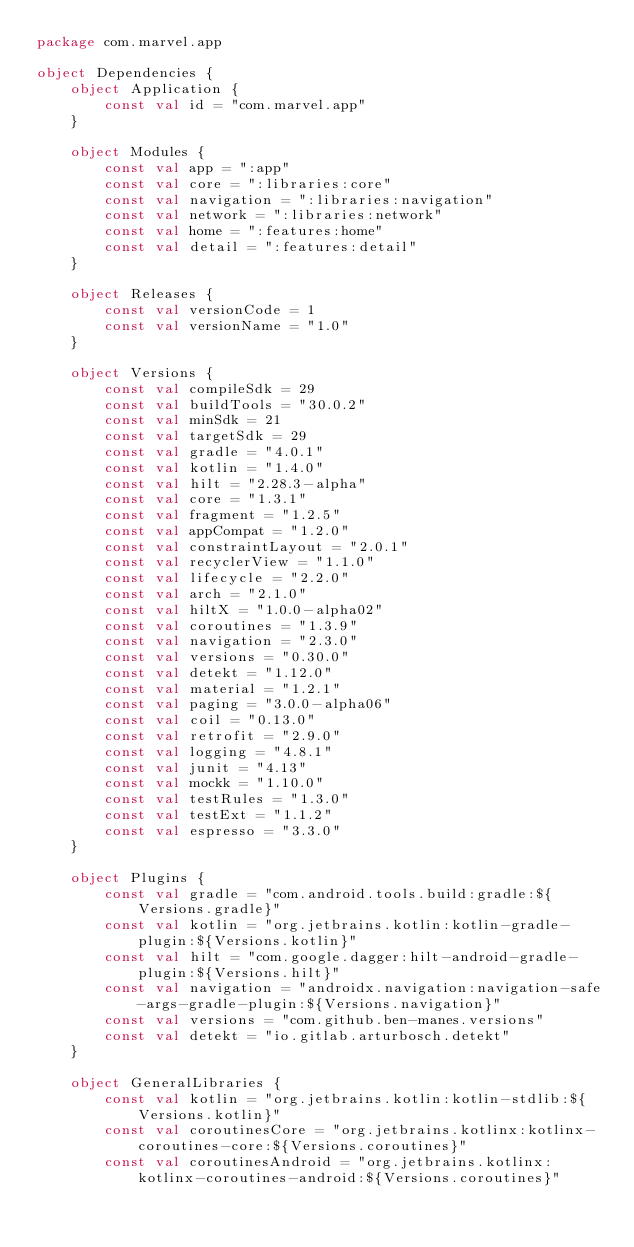<code> <loc_0><loc_0><loc_500><loc_500><_Kotlin_>package com.marvel.app

object Dependencies {
    object Application {
        const val id = "com.marvel.app"
    }

    object Modules {
        const val app = ":app"
        const val core = ":libraries:core"
        const val navigation = ":libraries:navigation"
        const val network = ":libraries:network"
        const val home = ":features:home"
        const val detail = ":features:detail"
    }

    object Releases {
        const val versionCode = 1
        const val versionName = "1.0"
    }

    object Versions {
        const val compileSdk = 29
        const val buildTools = "30.0.2"
        const val minSdk = 21
        const val targetSdk = 29
        const val gradle = "4.0.1"
        const val kotlin = "1.4.0"
        const val hilt = "2.28.3-alpha"
        const val core = "1.3.1"
        const val fragment = "1.2.5"
        const val appCompat = "1.2.0"
        const val constraintLayout = "2.0.1"
        const val recyclerView = "1.1.0"
        const val lifecycle = "2.2.0"
        const val arch = "2.1.0"
        const val hiltX = "1.0.0-alpha02"
        const val coroutines = "1.3.9"
        const val navigation = "2.3.0"
        const val versions = "0.30.0"
        const val detekt = "1.12.0"
        const val material = "1.2.1"
        const val paging = "3.0.0-alpha06"
        const val coil = "0.13.0"
        const val retrofit = "2.9.0"
        const val logging = "4.8.1"
        const val junit = "4.13"
        const val mockk = "1.10.0"
        const val testRules = "1.3.0"
        const val testExt = "1.1.2"
        const val espresso = "3.3.0"
    }

    object Plugins {
        const val gradle = "com.android.tools.build:gradle:${Versions.gradle}"
        const val kotlin = "org.jetbrains.kotlin:kotlin-gradle-plugin:${Versions.kotlin}"
        const val hilt = "com.google.dagger:hilt-android-gradle-plugin:${Versions.hilt}"
        const val navigation = "androidx.navigation:navigation-safe-args-gradle-plugin:${Versions.navigation}"
        const val versions = "com.github.ben-manes.versions"
        const val detekt = "io.gitlab.arturbosch.detekt"
    }

    object GeneralLibraries {
        const val kotlin = "org.jetbrains.kotlin:kotlin-stdlib:${Versions.kotlin}"
        const val coroutinesCore = "org.jetbrains.kotlinx:kotlinx-coroutines-core:${Versions.coroutines}"
        const val coroutinesAndroid = "org.jetbrains.kotlinx:kotlinx-coroutines-android:${Versions.coroutines}"</code> 